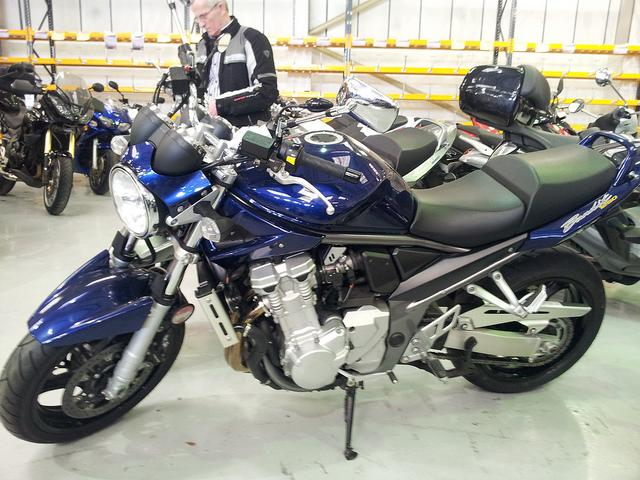What is he doing? Please explain your reasoning. viewing motorcycles. He's looking at motorbikes. 